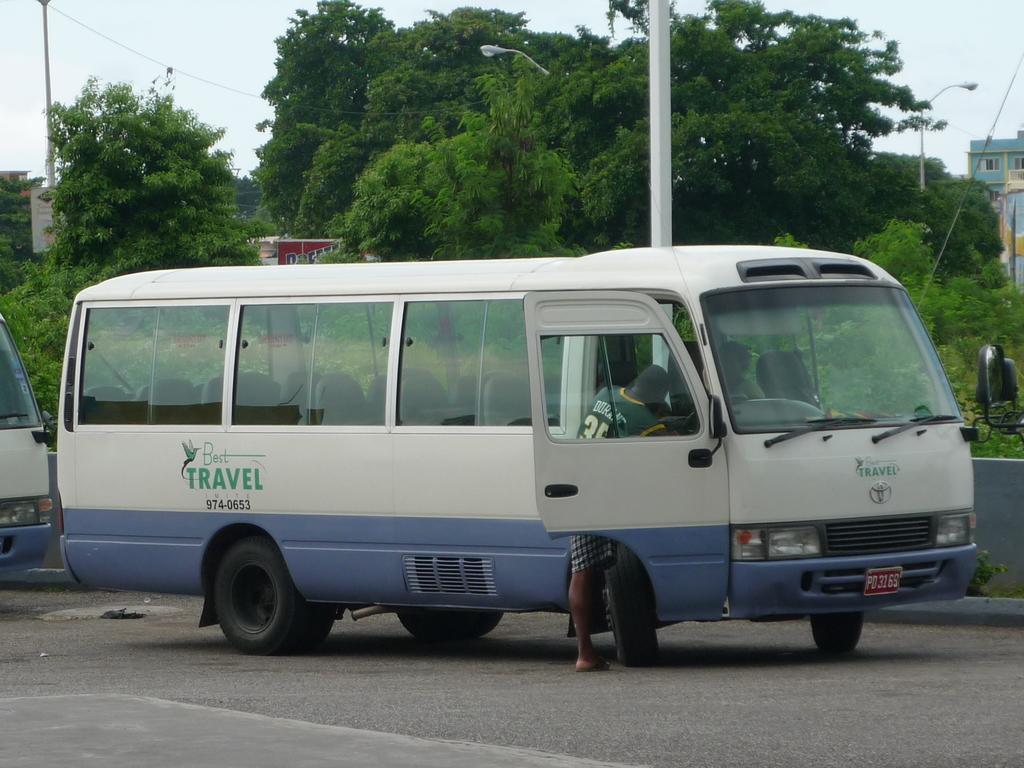What is the company's phone number?
Ensure brevity in your answer.  974-0653. What is the name of the company?
Make the answer very short. Best travel. 